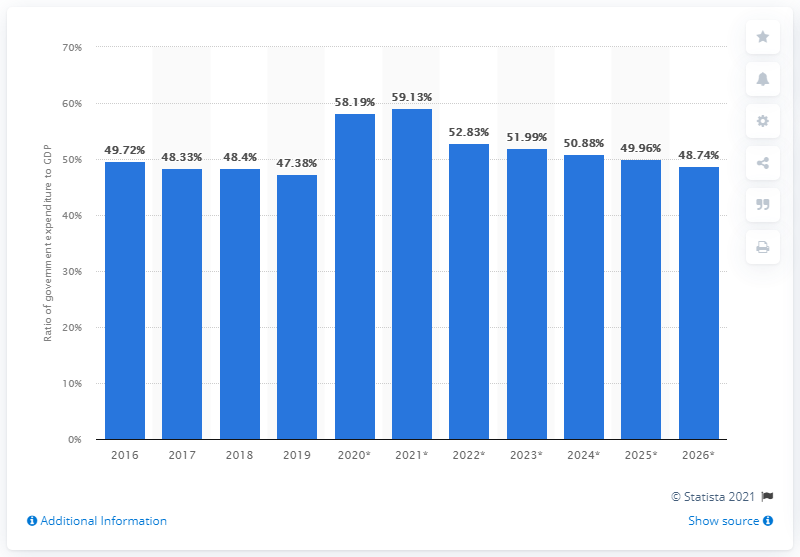Identify some key points in this picture. In 2019, Greece's gross domestic product (GDP) was 47.38% of its total annual spending. 